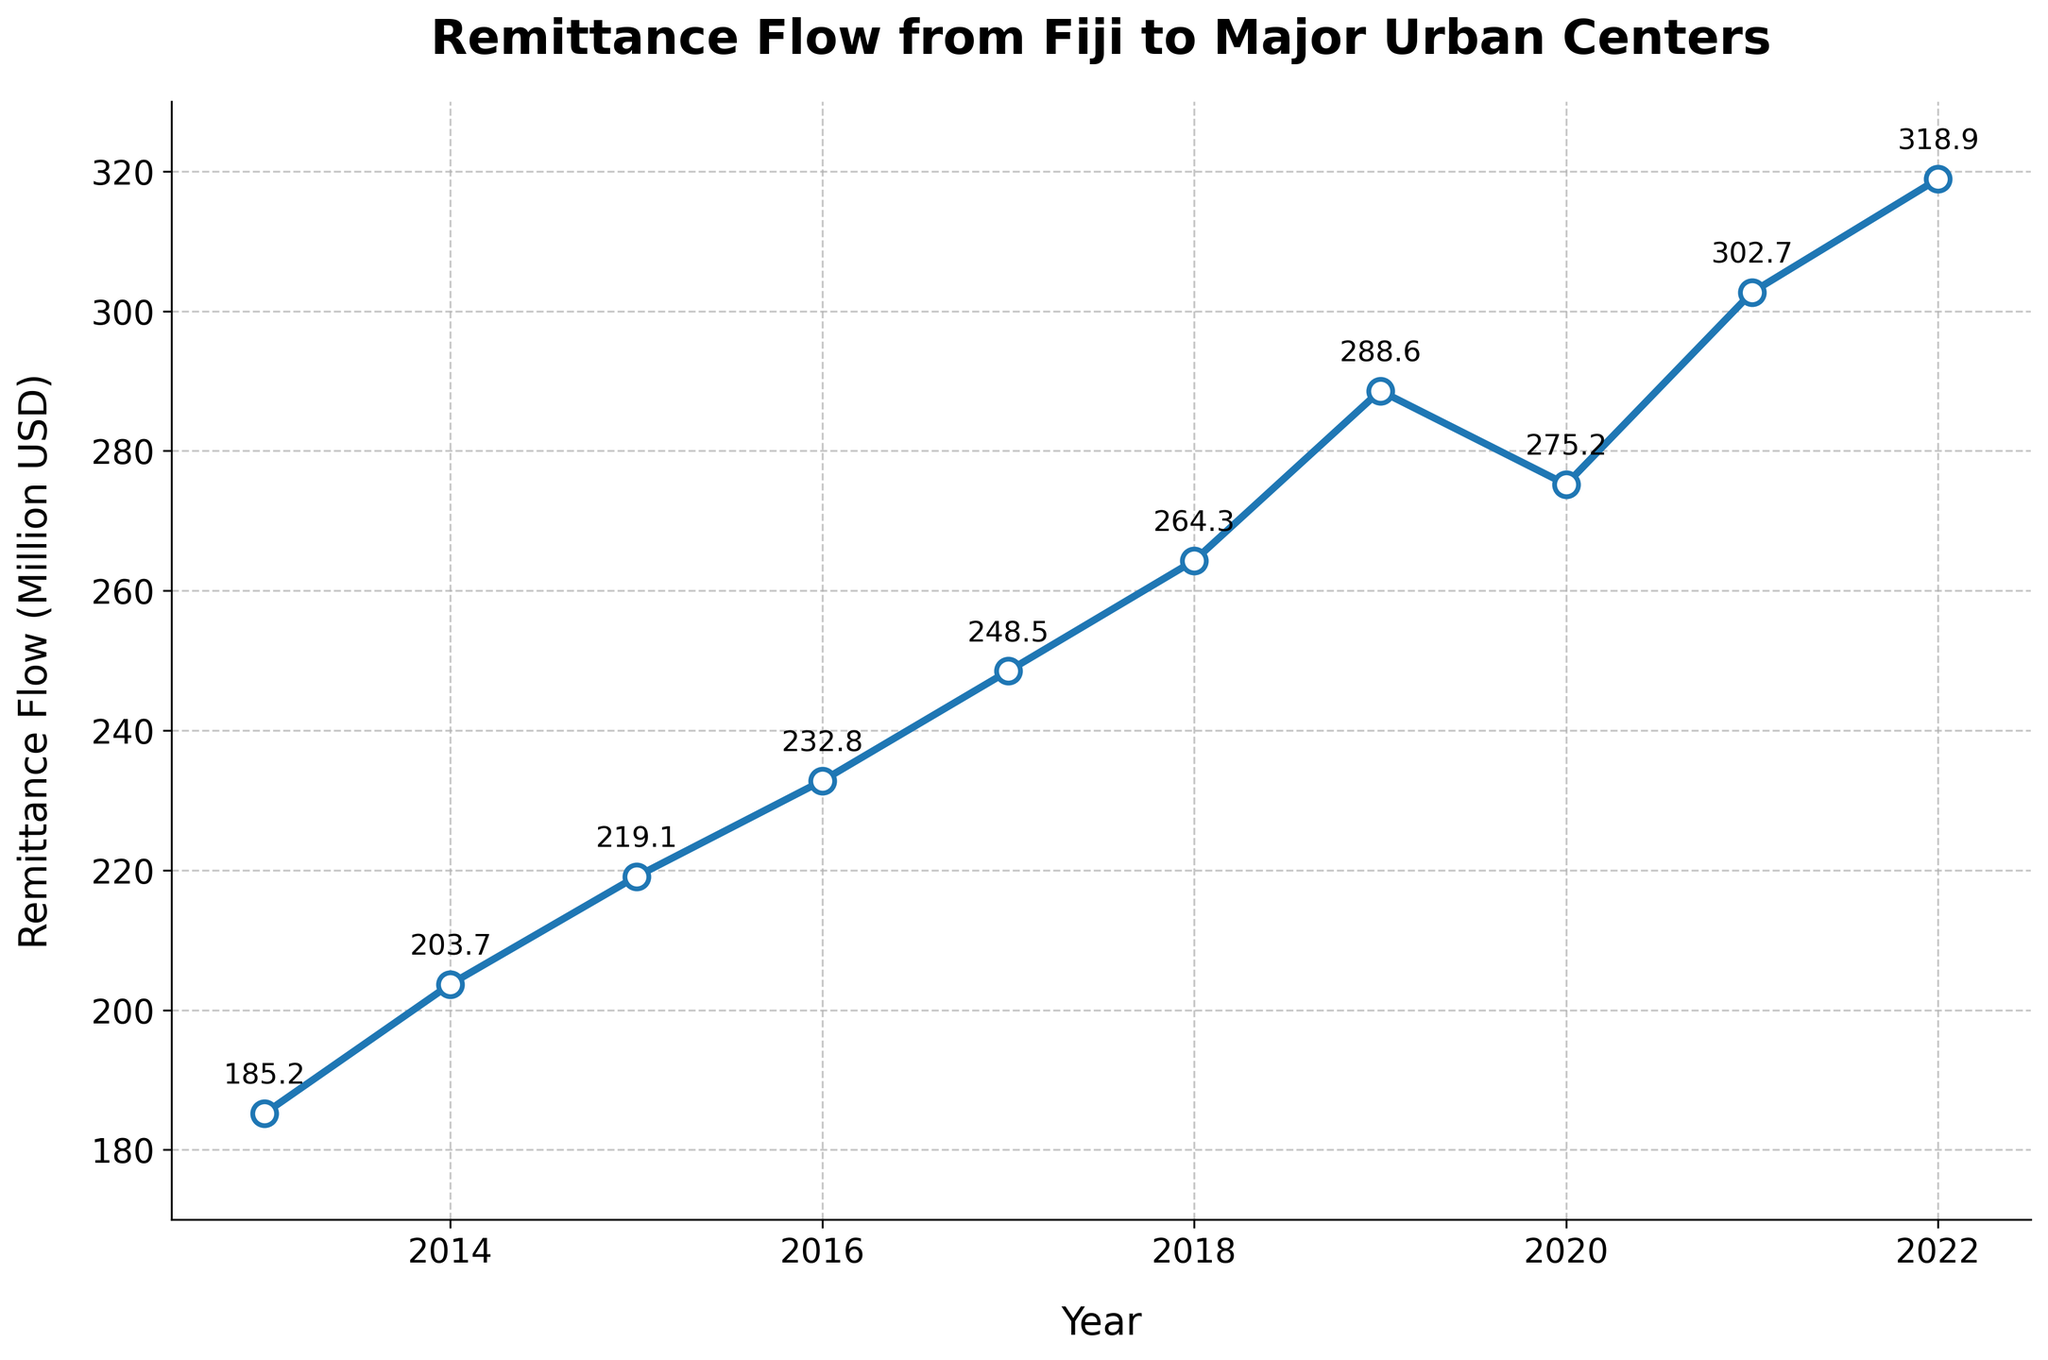What's the highest remittance flow recorded over the past decade? To find the highest remittance flow, look at the y-values (Remittance Flow in Million USD) along the line chart and identify the maximum value.
Answer: 318.9 Which year shows the lowest remittance flow? To determine this, look for the lowest point on the line chart and check the corresponding year on the x-axis.
Answer: 2013 How much did the remittance flow increase from 2013 to 2019? Note the remittance flow in 2013 (185.2 million USD) and in 2019 (288.6 million USD). Subtract the two values: 288.6 - 185.2.
Answer: 103.4 What is the average remittance flow over the past decade? Summing all the remittance flows from 2013 to 2022 (185.2 + 203.7 + 219.1 + 232.8 + 248.5 + 264.3 + 288.6 + 275.2 + 302.7 + 318.9) and then dividing by the number of years (10).
Answer: 253.9 Between which two consecutive years did the remittance flow decrease? Look for downward slopes on the line chart. Identify the years at the start and end of the downward segments. Here, it descends between 2019 and 2020.
Answer: 2019 and 2020 Between 2017 and 2022, which year had the highest rate of increase in remittance flow? Calculate the rate of increase year-over-year between 2017 and 2022 (248.5 to 318.9). Compare the rates: 264.3-248.5 (2017-2018) = 15.8, 288.6-264.3 (2018-2019) = 24.3, 275.2-288.6 (2019-2020) = -13.4, 302.7-275.2 (2020-2021) = 27.5, 318.9-302.7 (2021-2022) = 16.2. The highest rate is between 2020-2021.
Answer: 2020 to 2021 How much did the remittance flow increase from 2016 to 2021? Note the remittance flow in 2016 (232.8 million USD) and in 2021 (302.7 million USD). Subtract the two values: 302.7 - 232.8.
Answer: 69.9 Which years show a continuous increase in remittance flow for at least 5 years? Observe where the line chart rises consistently without dropping. Continuous increases occur from 2016 to 2019 and again from 2020 to 2022. Hence, only the period from 2016 to 2019 meets the 5-year requirement.
Answer: 2013 to 2019 